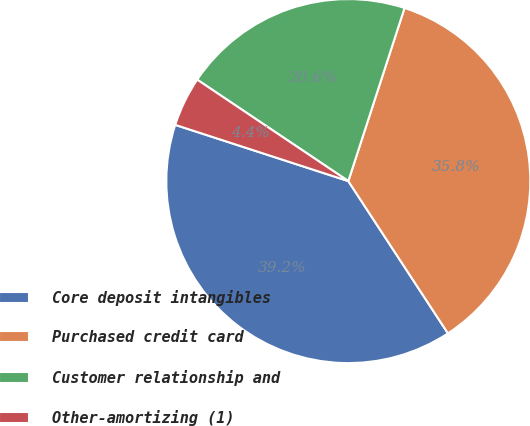Convert chart to OTSL. <chart><loc_0><loc_0><loc_500><loc_500><pie_chart><fcel>Core deposit intangibles<fcel>Purchased credit card<fcel>Customer relationship and<fcel>Other-amortizing (1)<nl><fcel>39.22%<fcel>35.78%<fcel>20.59%<fcel>4.41%<nl></chart> 